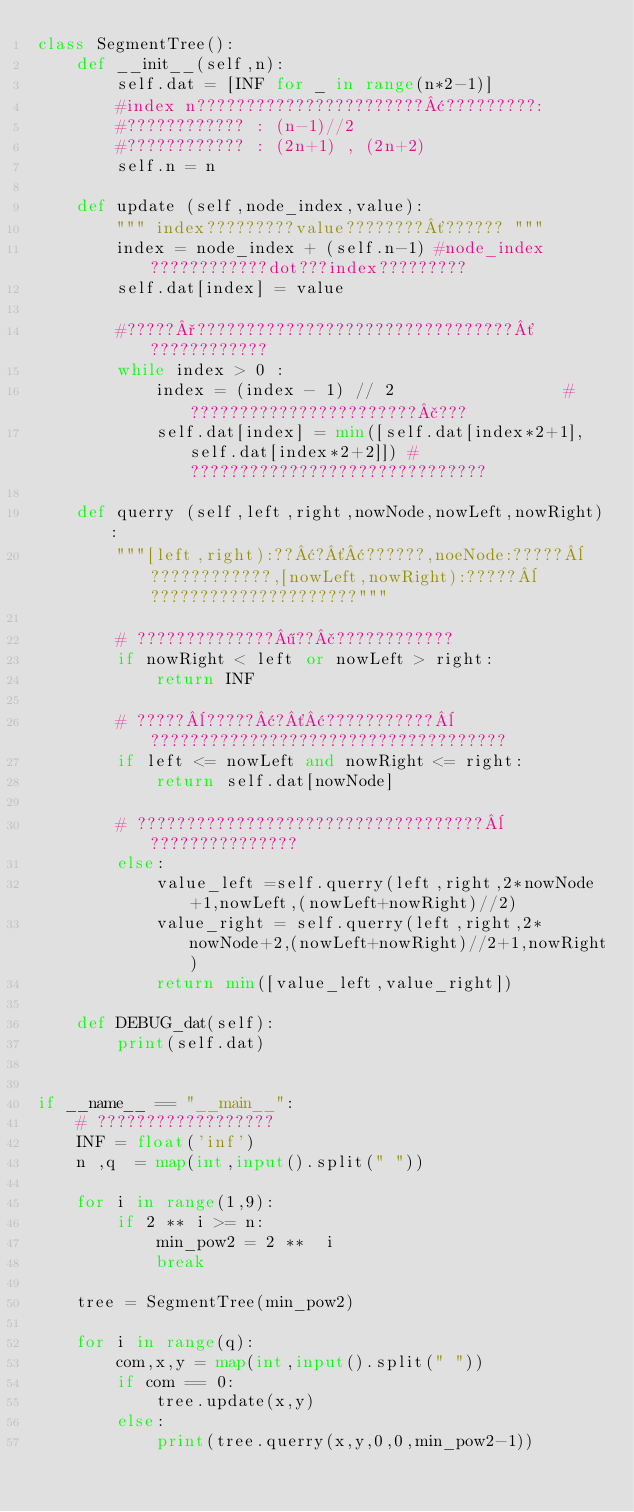<code> <loc_0><loc_0><loc_500><loc_500><_Python_>class SegmentTree():
	def __init__(self,n):
		self.dat = [INF for _ in range(n*2-1)]
		#index n???????????????????????¢?????????:
		#???????????? : (n-1)//2
		#???????????? : (2n+1) , (2n+2)
		self.n = n

	def update (self,node_index,value):
		""" index?????????value????????´?????? """
		index = node_index + (self.n-1) #node_index????????????dot???index?????????
		self.dat[index] = value

		#?????°????????????????????????????????´????????????
		while index > 0 :
			index = (index - 1) // 2				 #???????????????????????£???
			self.dat[index] = min([self.dat[index*2+1],self.dat[index*2+2]]) #??????????????????????????????

	def querry (self,left,right,nowNode,nowLeft,nowRight):
		"""[left,right):??¢?´¢??????,noeNode:?????¨????????????,[nowLeft,nowRight):?????¨?????????????????????"""

		# ??????????????¶??£????????????
		if nowRight < left or nowLeft > right:
			return INF

		# ?????¨?????¢?´¢???????????¨????????????????????????????????????
		if left <= nowLeft and nowRight <= right:
			return self.dat[nowNode]

		# ???????????????????????????????????¨???????????????
		else:
			value_left =self.querry(left,right,2*nowNode+1,nowLeft,(nowLeft+nowRight)//2)
			value_right = self.querry(left,right,2*nowNode+2,(nowLeft+nowRight)//2+1,nowRight)
			return min([value_left,value_right])

	def DEBUG_dat(self):
		print(self.dat)
		

if __name__ == "__main__":
	# ??????????????????
	INF = float('inf')
	n ,q  = map(int,input().split(" "))

	for i in range(1,9):
		if 2 ** i >= n:
			min_pow2 = 2 **  i
			break

	tree = SegmentTree(min_pow2)

	for i in range(q):
		com,x,y = map(int,input().split(" "))
		if com == 0:
			tree.update(x,y)
		else:
			print(tree.querry(x,y,0,0,min_pow2-1))</code> 